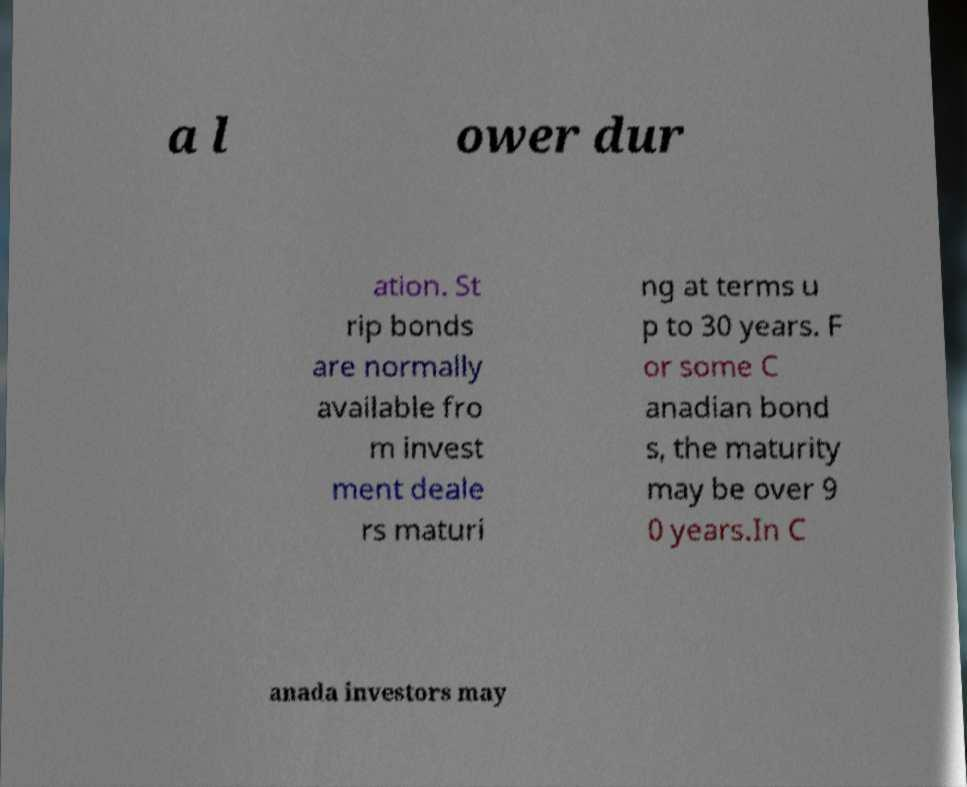Can you accurately transcribe the text from the provided image for me? a l ower dur ation. St rip bonds are normally available fro m invest ment deale rs maturi ng at terms u p to 30 years. F or some C anadian bond s, the maturity may be over 9 0 years.In C anada investors may 